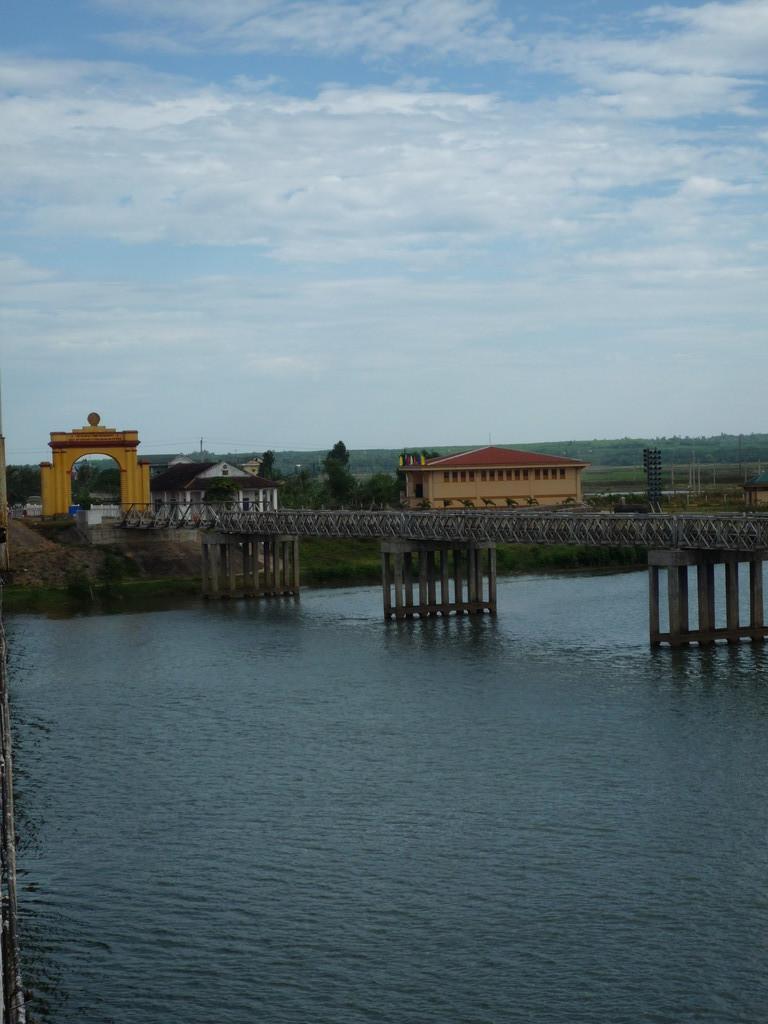How would you summarize this image in a sentence or two? This is a freshwater river. Above this water river there is a bridge to travel from one end to another end. Far there is a house in cream color, with a roof top in red color. These is an arc in gold color. Sky is cloudy. Far there are number of trees in green color. 